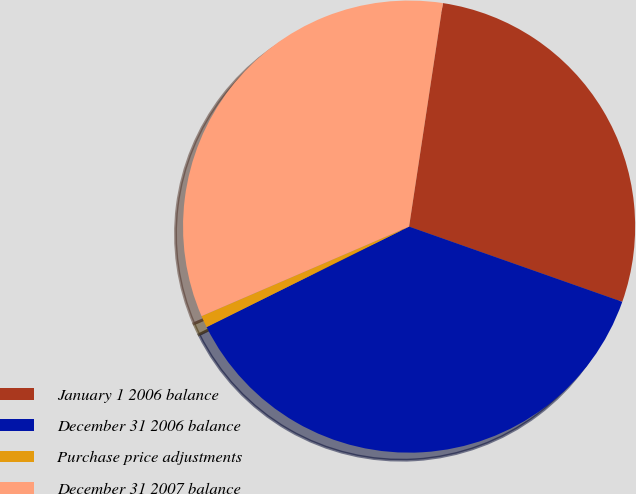Convert chart. <chart><loc_0><loc_0><loc_500><loc_500><pie_chart><fcel>January 1 2006 balance<fcel>December 31 2006 balance<fcel>Purchase price adjustments<fcel>December 31 2007 balance<nl><fcel>28.01%<fcel>37.27%<fcel>0.85%<fcel>33.87%<nl></chart> 